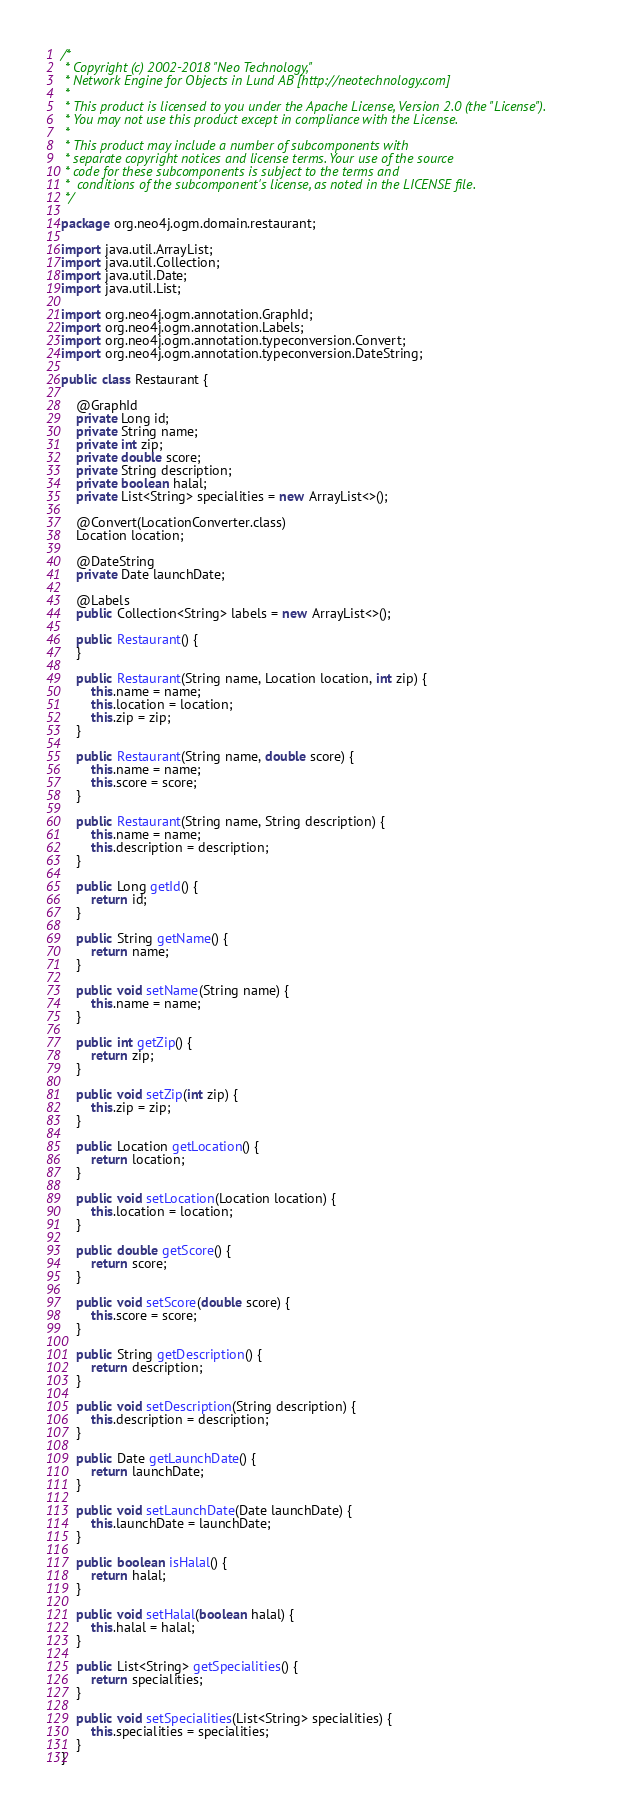<code> <loc_0><loc_0><loc_500><loc_500><_Java_>/*
 * Copyright (c) 2002-2018 "Neo Technology,"
 * Network Engine for Objects in Lund AB [http://neotechnology.com]
 *
 * This product is licensed to you under the Apache License, Version 2.0 (the "License").
 * You may not use this product except in compliance with the License.
 *
 * This product may include a number of subcomponents with
 * separate copyright notices and license terms. Your use of the source
 * code for these subcomponents is subject to the terms and
 *  conditions of the subcomponent's license, as noted in the LICENSE file.
 */

package org.neo4j.ogm.domain.restaurant;

import java.util.ArrayList;
import java.util.Collection;
import java.util.Date;
import java.util.List;

import org.neo4j.ogm.annotation.GraphId;
import org.neo4j.ogm.annotation.Labels;
import org.neo4j.ogm.annotation.typeconversion.Convert;
import org.neo4j.ogm.annotation.typeconversion.DateString;

public class Restaurant {

    @GraphId
    private Long id;
    private String name;
    private int zip;
    private double score;
    private String description;
    private boolean halal;
    private List<String> specialities = new ArrayList<>();

    @Convert(LocationConverter.class)
    Location location;

    @DateString
    private Date launchDate;

    @Labels
    public Collection<String> labels = new ArrayList<>();

    public Restaurant() {
    }

    public Restaurant(String name, Location location, int zip) {
        this.name = name;
        this.location = location;
        this.zip = zip;
    }

    public Restaurant(String name, double score) {
        this.name = name;
        this.score = score;
    }

    public Restaurant(String name, String description) {
        this.name = name;
        this.description = description;
    }

    public Long getId() {
        return id;
    }

    public String getName() {
        return name;
    }

    public void setName(String name) {
        this.name = name;
    }

    public int getZip() {
        return zip;
    }

    public void setZip(int zip) {
        this.zip = zip;
    }

    public Location getLocation() {
        return location;
    }

    public void setLocation(Location location) {
        this.location = location;
    }

    public double getScore() {
        return score;
    }

    public void setScore(double score) {
        this.score = score;
    }

    public String getDescription() {
        return description;
    }

    public void setDescription(String description) {
        this.description = description;
    }

    public Date getLaunchDate() {
        return launchDate;
    }

    public void setLaunchDate(Date launchDate) {
        this.launchDate = launchDate;
    }

    public boolean isHalal() {
        return halal;
    }

    public void setHalal(boolean halal) {
        this.halal = halal;
    }

    public List<String> getSpecialities() {
        return specialities;
    }

    public void setSpecialities(List<String> specialities) {
        this.specialities = specialities;
    }
}
</code> 